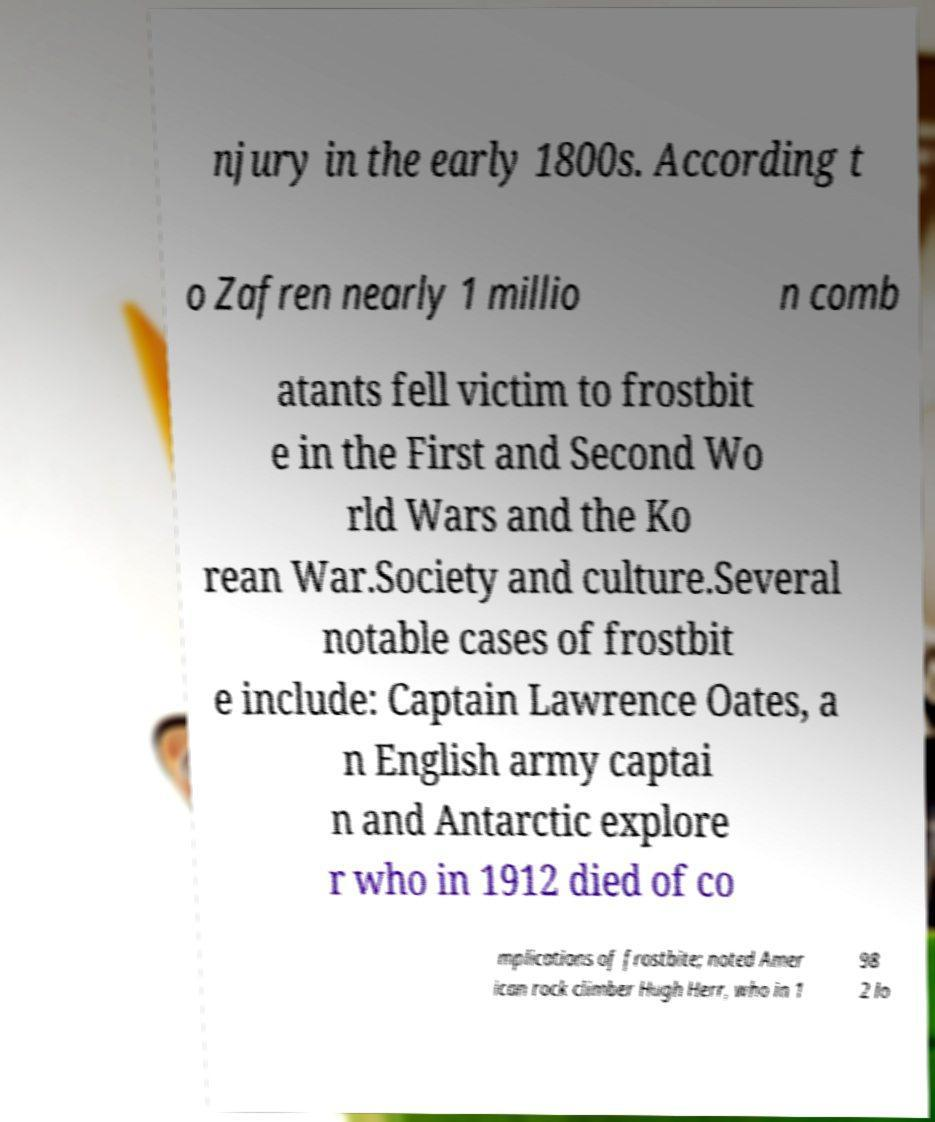What messages or text are displayed in this image? I need them in a readable, typed format. njury in the early 1800s. According t o Zafren nearly 1 millio n comb atants fell victim to frostbit e in the First and Second Wo rld Wars and the Ko rean War.Society and culture.Several notable cases of frostbit e include: Captain Lawrence Oates, a n English army captai n and Antarctic explore r who in 1912 died of co mplications of frostbite; noted Amer ican rock climber Hugh Herr, who in 1 98 2 lo 